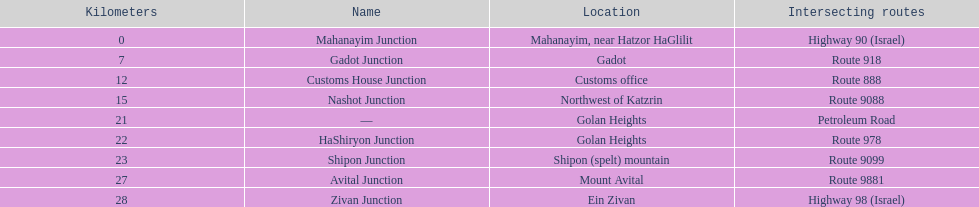Which junction on highway 91 is closer to ein zivan, gadot junction or shipon junction? Gadot Junction. 